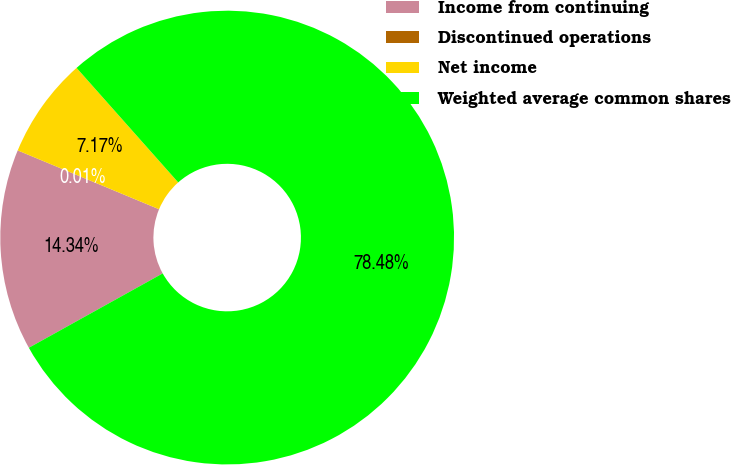Convert chart to OTSL. <chart><loc_0><loc_0><loc_500><loc_500><pie_chart><fcel>Income from continuing<fcel>Discontinued operations<fcel>Net income<fcel>Weighted average common shares<nl><fcel>14.34%<fcel>0.01%<fcel>7.17%<fcel>78.48%<nl></chart> 